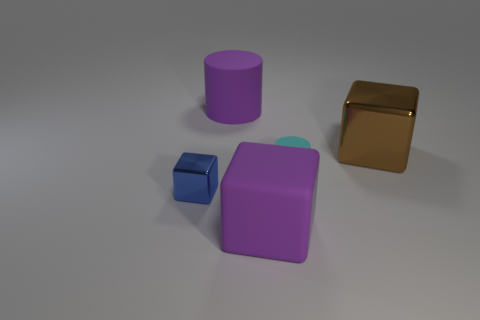Add 2 big things. How many objects exist? 7 Subtract all cubes. How many objects are left? 2 Add 4 tiny rubber cylinders. How many tiny rubber cylinders are left? 5 Add 5 big matte cubes. How many big matte cubes exist? 6 Subtract 0 red cylinders. How many objects are left? 5 Subtract all large purple blocks. Subtract all purple cylinders. How many objects are left? 3 